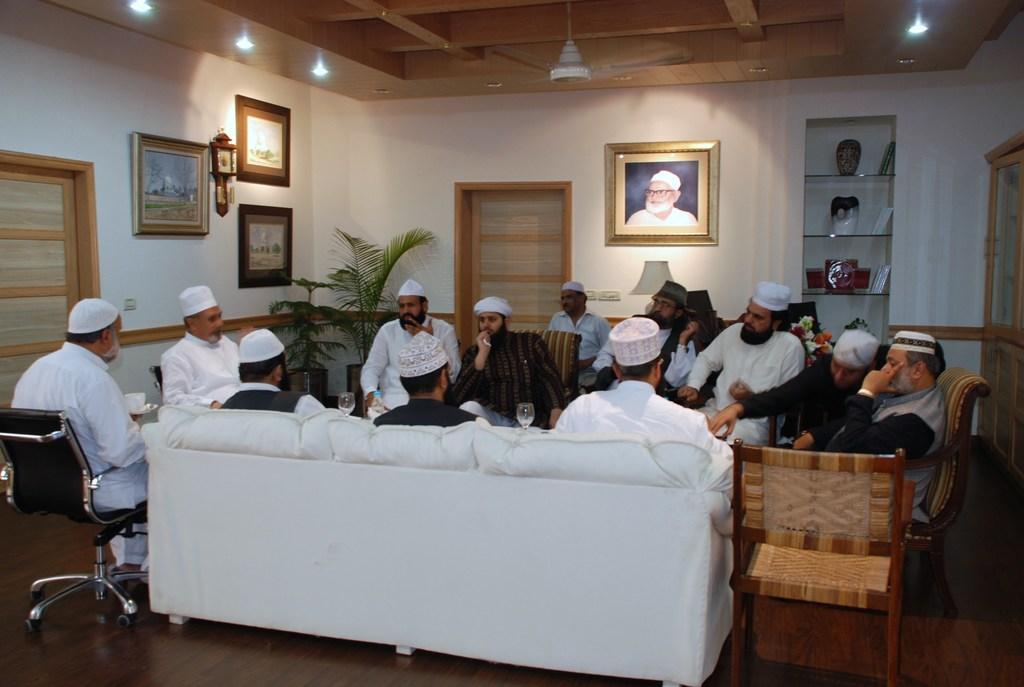Describe this image in one or two sentences. As we can see in the image there is a white color wall. On wall there is a clock and photo frames and there are sofas and on sofas there are few people sitting and on the left side there is a plant. 